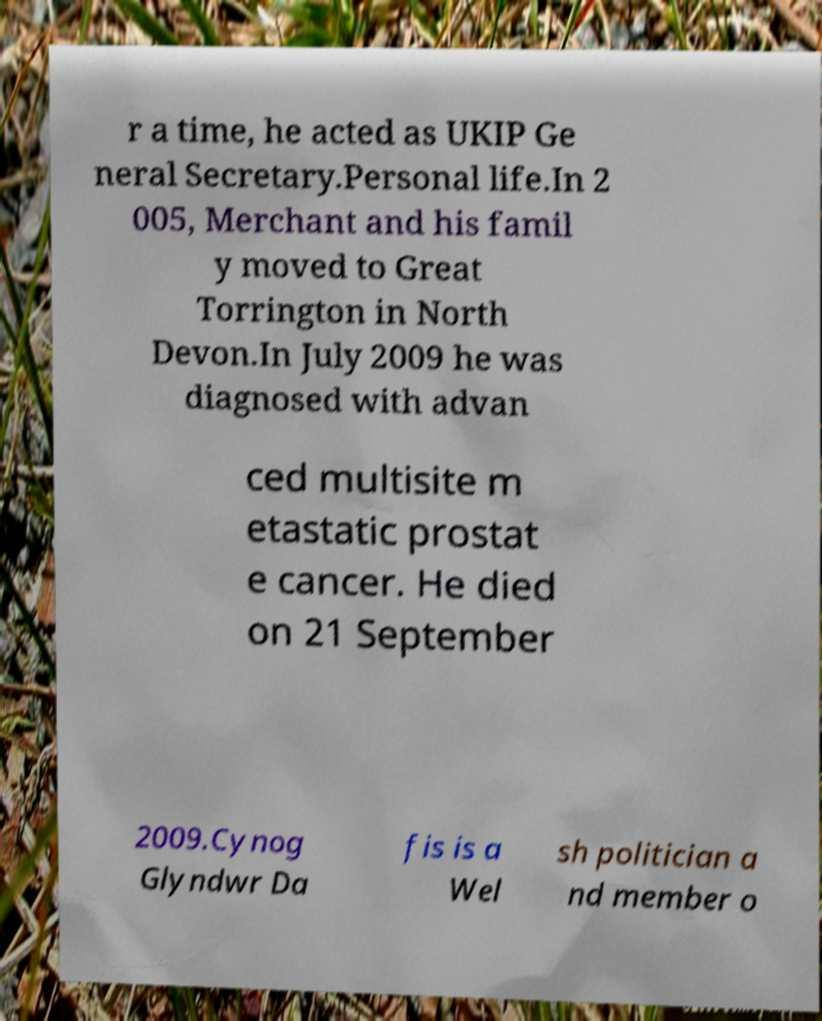Could you assist in decoding the text presented in this image and type it out clearly? r a time, he acted as UKIP Ge neral Secretary.Personal life.In 2 005, Merchant and his famil y moved to Great Torrington in North Devon.In July 2009 he was diagnosed with advan ced multisite m etastatic prostat e cancer. He died on 21 September 2009.Cynog Glyndwr Da fis is a Wel sh politician a nd member o 